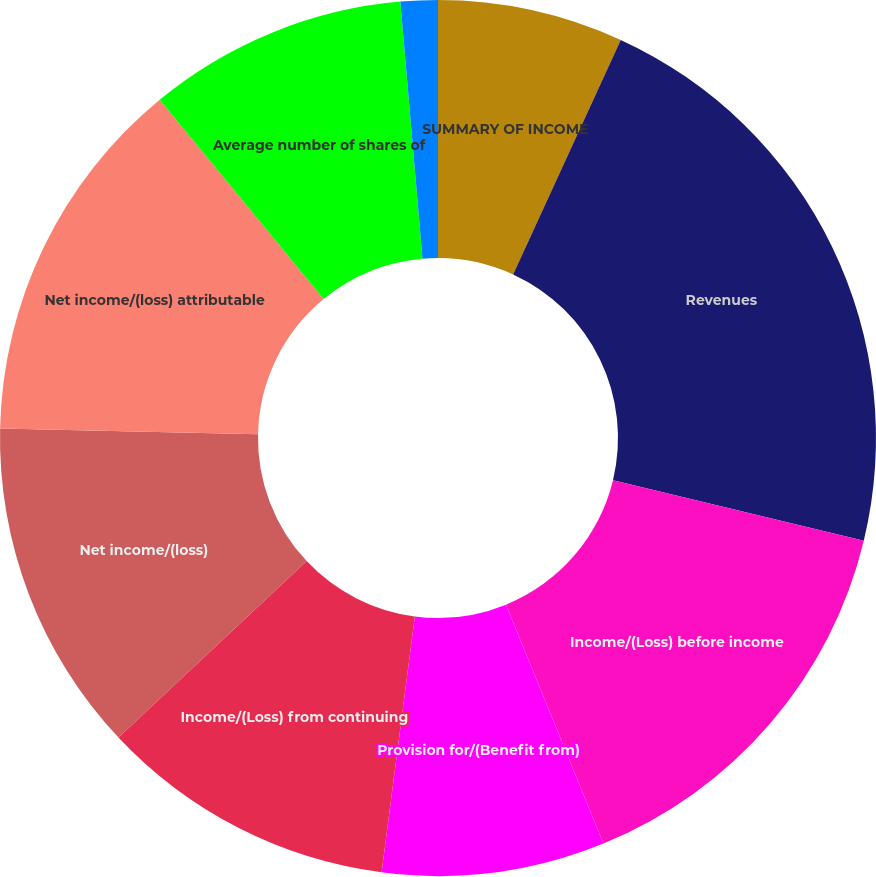<chart> <loc_0><loc_0><loc_500><loc_500><pie_chart><fcel>SUMMARY OF INCOME<fcel>Revenues<fcel>Income/(Loss) before income<fcel>Provision for/(Benefit from)<fcel>Income/(Loss) from continuing<fcel>Net income/(loss)<fcel>Net income/(loss) attributable<fcel>Average number of shares of<fcel>Basic income/(loss)<fcel>Diluted income/(loss)<nl><fcel>6.85%<fcel>21.92%<fcel>15.07%<fcel>8.22%<fcel>10.96%<fcel>12.33%<fcel>13.7%<fcel>9.59%<fcel>1.37%<fcel>0.0%<nl></chart> 